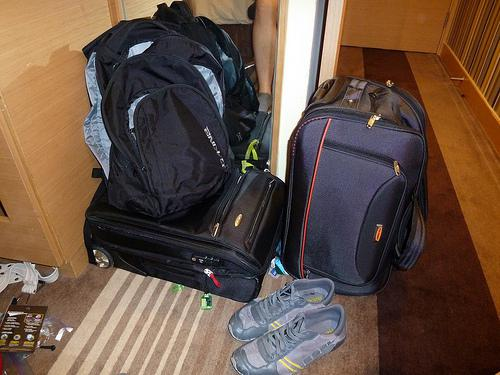Question: how many shoes?
Choices:
A. 2.
B. 1.
C. 3.
D. 4.
Answer with the letter. Answer: B Question: why are the bags there?
Choices:
A. Put in the garage.
B. Packing up.
C. Going on a trip.
D. Washing inside.
Answer with the letter. Answer: C Question: what color are the shoes?
Choices:
A. Brown.
B. Black.
C. Grey.
D. Red.
Answer with the letter. Answer: C Question: who is in photo?
Choices:
A. Noone.
B. Dog.
C. Sheep.
D. President.
Answer with the letter. Answer: A Question: how many bags?
Choices:
A. 3.
B. 2.
C. 1.
D. 4.
Answer with the letter. Answer: A Question: what has stripes?
Choices:
A. Cat.
B. Rug.
C. Dress.
D. Chair.
Answer with the letter. Answer: B Question: where is the cord?
Choices:
A. On the vacuum.
B. On the radio.
C. Bottom left.
D. On the TV.
Answer with the letter. Answer: C 